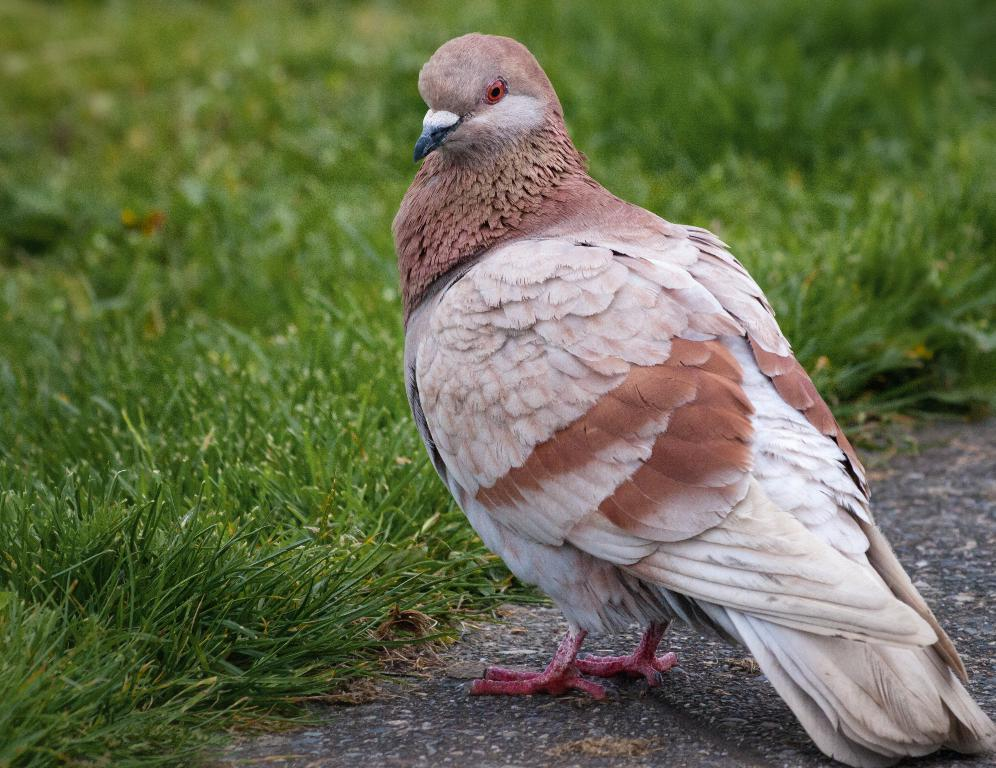What type of animal can be seen in the image? There is a bird in the image. What is the bird situated in front of? The bird is visible in front of a crop. What type of food is the bird holding in its beak in the image? There is no food visible in the bird's beak in the image. What type of pail can be seen near the bird in the image? There is no pail present in the image. 